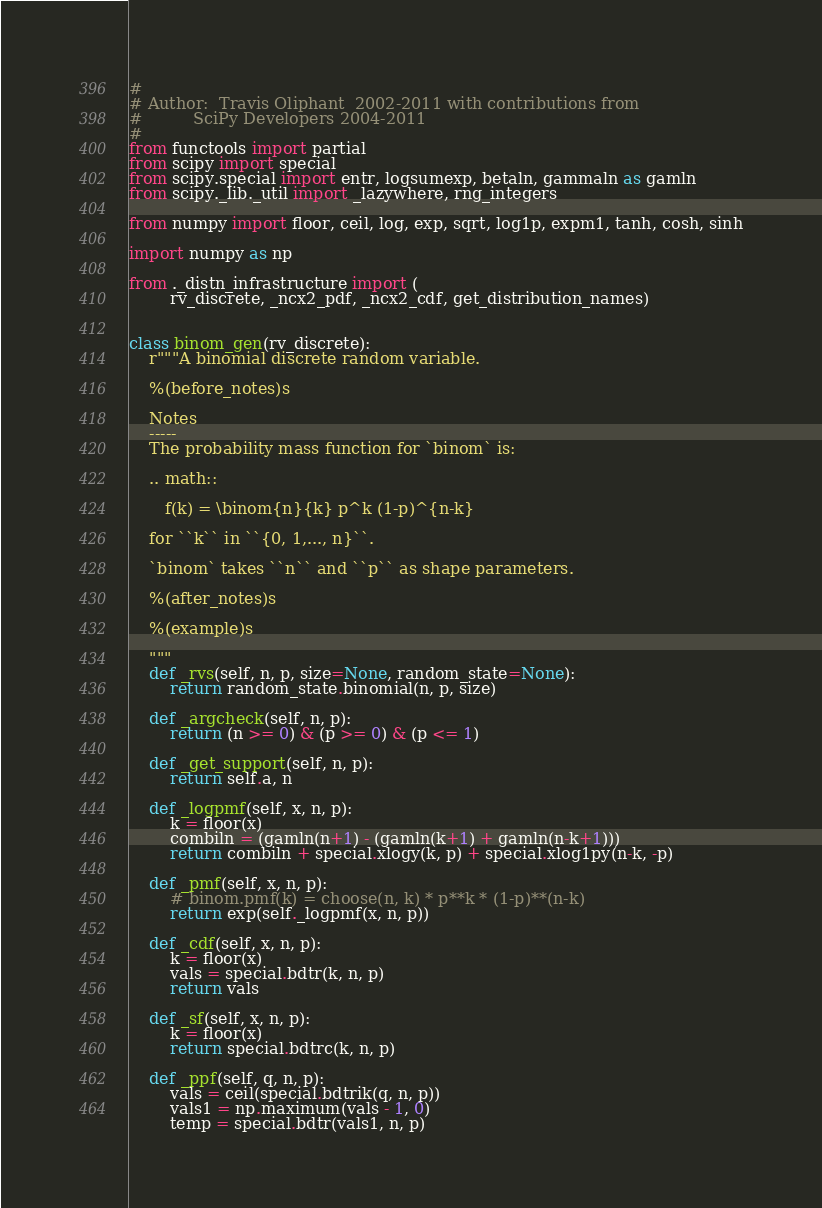<code> <loc_0><loc_0><loc_500><loc_500><_Python_>#
# Author:  Travis Oliphant  2002-2011 with contributions from
#          SciPy Developers 2004-2011
#
from functools import partial
from scipy import special
from scipy.special import entr, logsumexp, betaln, gammaln as gamln
from scipy._lib._util import _lazywhere, rng_integers

from numpy import floor, ceil, log, exp, sqrt, log1p, expm1, tanh, cosh, sinh

import numpy as np

from ._distn_infrastructure import (
        rv_discrete, _ncx2_pdf, _ncx2_cdf, get_distribution_names)


class binom_gen(rv_discrete):
    r"""A binomial discrete random variable.

    %(before_notes)s

    Notes
    -----
    The probability mass function for `binom` is:

    .. math::

       f(k) = \binom{n}{k} p^k (1-p)^{n-k}

    for ``k`` in ``{0, 1,..., n}``.

    `binom` takes ``n`` and ``p`` as shape parameters.

    %(after_notes)s

    %(example)s

    """
    def _rvs(self, n, p, size=None, random_state=None):
        return random_state.binomial(n, p, size)

    def _argcheck(self, n, p):
        return (n >= 0) & (p >= 0) & (p <= 1)

    def _get_support(self, n, p):
        return self.a, n

    def _logpmf(self, x, n, p):
        k = floor(x)
        combiln = (gamln(n+1) - (gamln(k+1) + gamln(n-k+1)))
        return combiln + special.xlogy(k, p) + special.xlog1py(n-k, -p)

    def _pmf(self, x, n, p):
        # binom.pmf(k) = choose(n, k) * p**k * (1-p)**(n-k)
        return exp(self._logpmf(x, n, p))

    def _cdf(self, x, n, p):
        k = floor(x)
        vals = special.bdtr(k, n, p)
        return vals

    def _sf(self, x, n, p):
        k = floor(x)
        return special.bdtrc(k, n, p)

    def _ppf(self, q, n, p):
        vals = ceil(special.bdtrik(q, n, p))
        vals1 = np.maximum(vals - 1, 0)
        temp = special.bdtr(vals1, n, p)</code> 